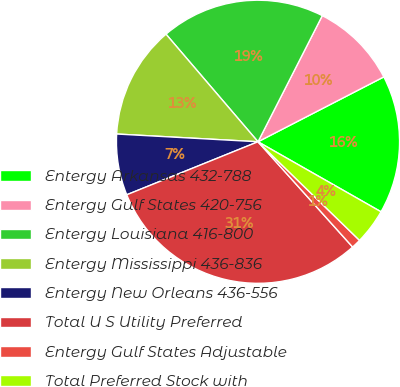Convert chart to OTSL. <chart><loc_0><loc_0><loc_500><loc_500><pie_chart><fcel>Entergy Arkansas 432-788<fcel>Entergy Gulf States 420-756<fcel>Entergy Louisiana 416-800<fcel>Entergy Mississippi 436-836<fcel>Entergy New Orleans 436-556<fcel>Total U S Utility Preferred<fcel>Entergy Gulf States Adjustable<fcel>Total Preferred Stock with<nl><fcel>15.81%<fcel>9.92%<fcel>18.76%<fcel>12.87%<fcel>6.98%<fcel>30.54%<fcel>1.08%<fcel>4.03%<nl></chart> 